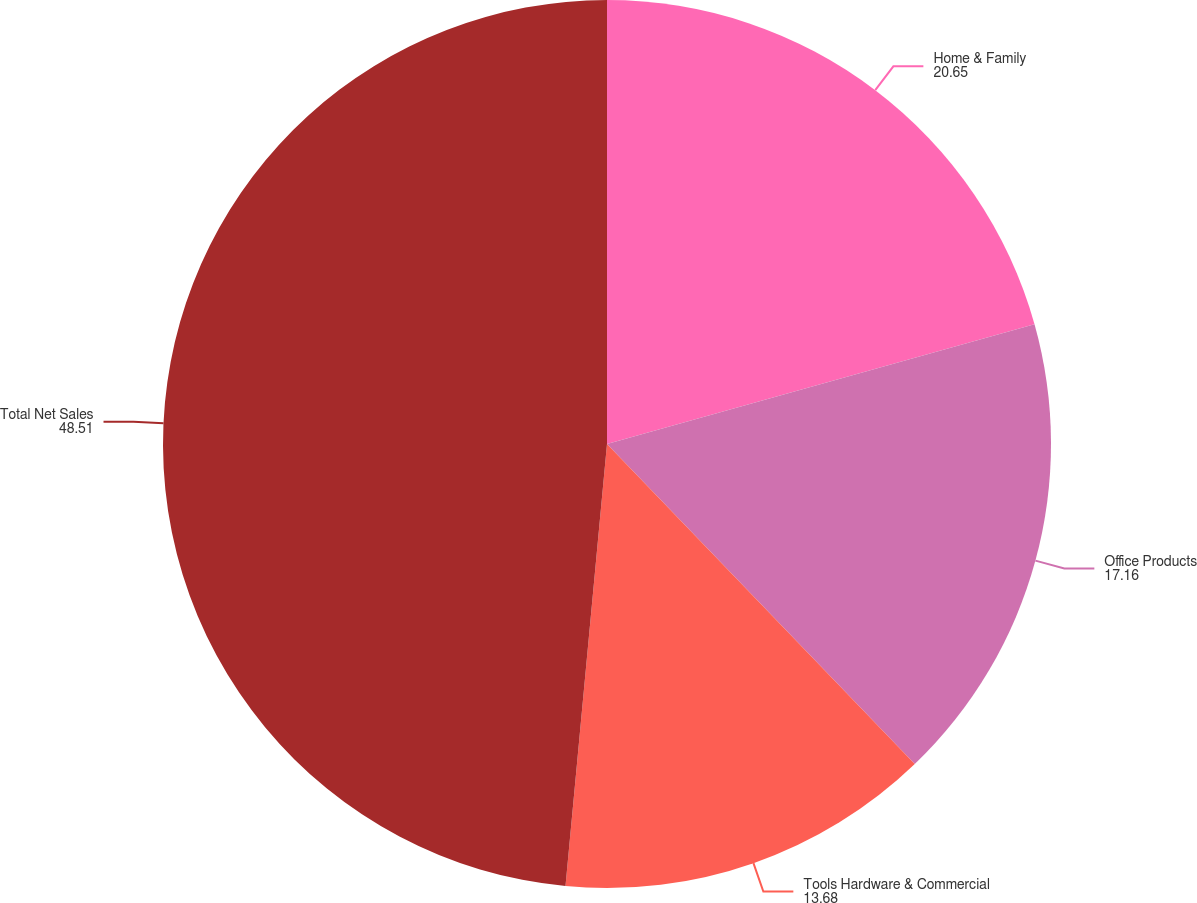Convert chart. <chart><loc_0><loc_0><loc_500><loc_500><pie_chart><fcel>Home & Family<fcel>Office Products<fcel>Tools Hardware & Commercial<fcel>Total Net Sales<nl><fcel>20.65%<fcel>17.16%<fcel>13.68%<fcel>48.51%<nl></chart> 